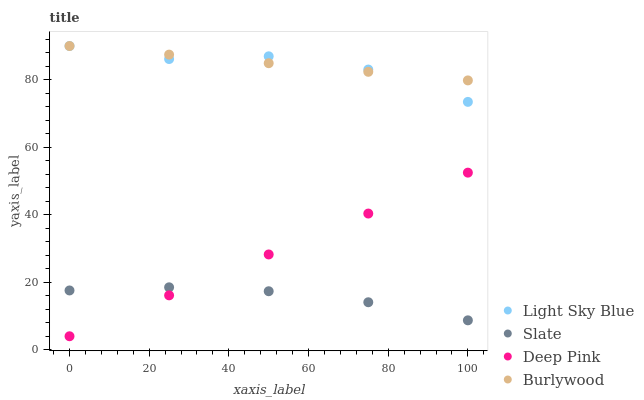Does Slate have the minimum area under the curve?
Answer yes or no. Yes. Does Burlywood have the maximum area under the curve?
Answer yes or no. Yes. Does Light Sky Blue have the minimum area under the curve?
Answer yes or no. No. Does Light Sky Blue have the maximum area under the curve?
Answer yes or no. No. Is Burlywood the smoothest?
Answer yes or no. Yes. Is Light Sky Blue the roughest?
Answer yes or no. Yes. Is Slate the smoothest?
Answer yes or no. No. Is Slate the roughest?
Answer yes or no. No. Does Deep Pink have the lowest value?
Answer yes or no. Yes. Does Slate have the lowest value?
Answer yes or no. No. Does Light Sky Blue have the highest value?
Answer yes or no. Yes. Does Slate have the highest value?
Answer yes or no. No. Is Deep Pink less than Burlywood?
Answer yes or no. Yes. Is Burlywood greater than Deep Pink?
Answer yes or no. Yes. Does Light Sky Blue intersect Burlywood?
Answer yes or no. Yes. Is Light Sky Blue less than Burlywood?
Answer yes or no. No. Is Light Sky Blue greater than Burlywood?
Answer yes or no. No. Does Deep Pink intersect Burlywood?
Answer yes or no. No. 